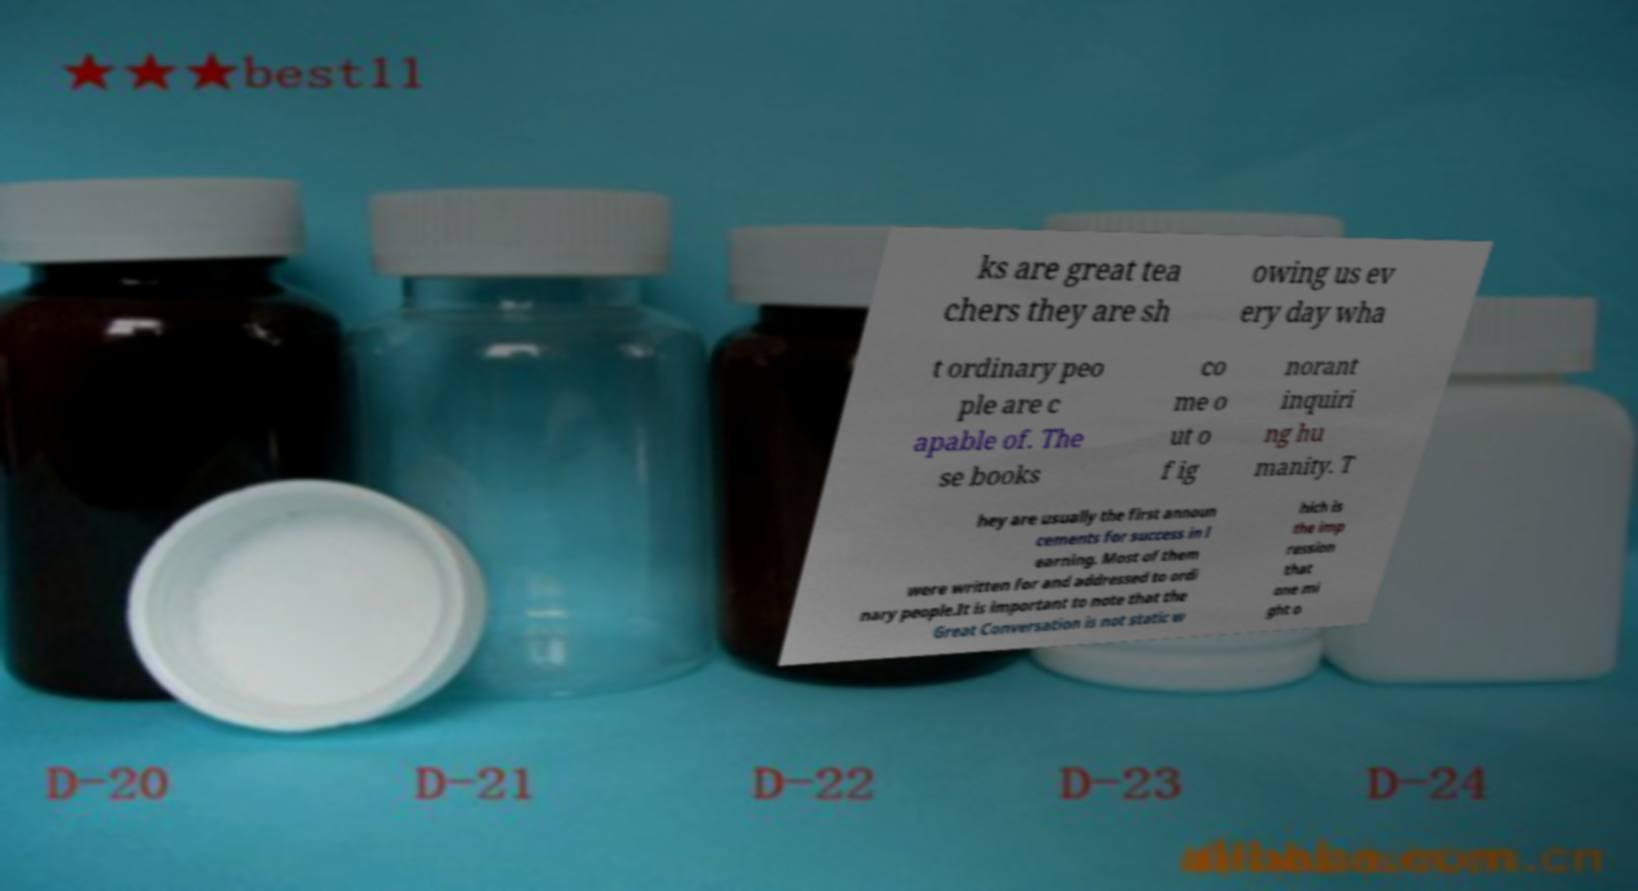There's text embedded in this image that I need extracted. Can you transcribe it verbatim? ks are great tea chers they are sh owing us ev ery day wha t ordinary peo ple are c apable of. The se books co me o ut o f ig norant inquiri ng hu manity. T hey are usually the first announ cements for success in l earning. Most of them were written for and addressed to ordi nary people.It is important to note that the Great Conversation is not static w hich is the imp ression that one mi ght o 